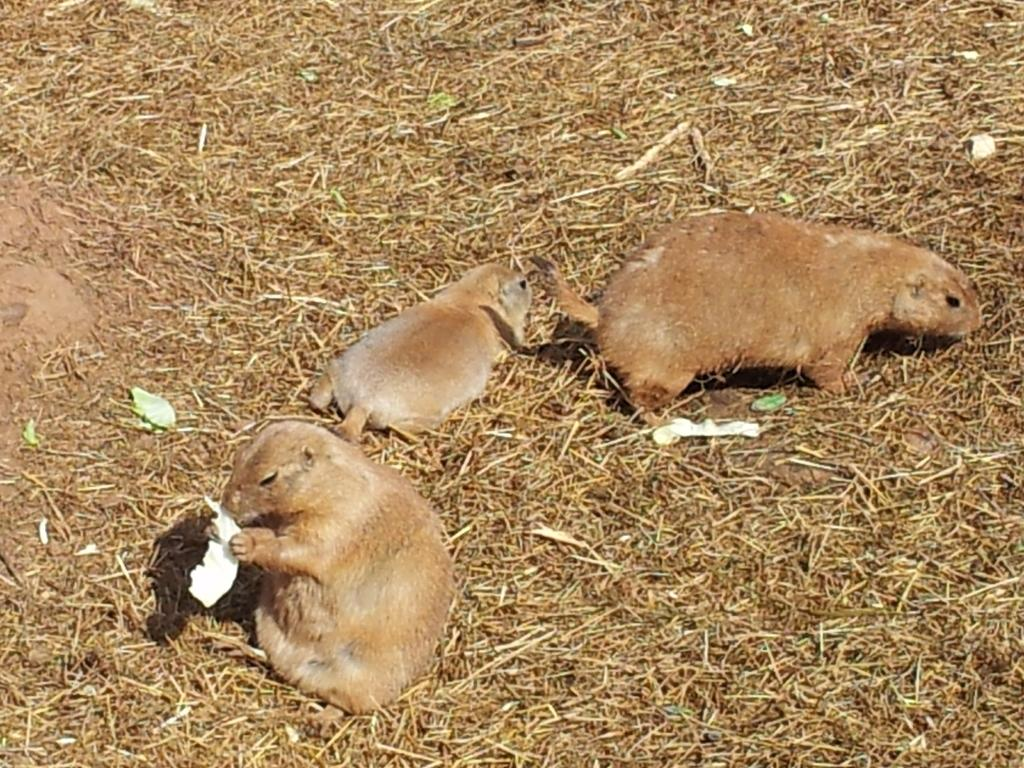What type of animal is in the image? There is a capybara in the image. Where is the capybara located? The capybara is on the ground. What type of drug is the capybara using in the image? There is no drug present in the image, and the capybara is not using any drug. 